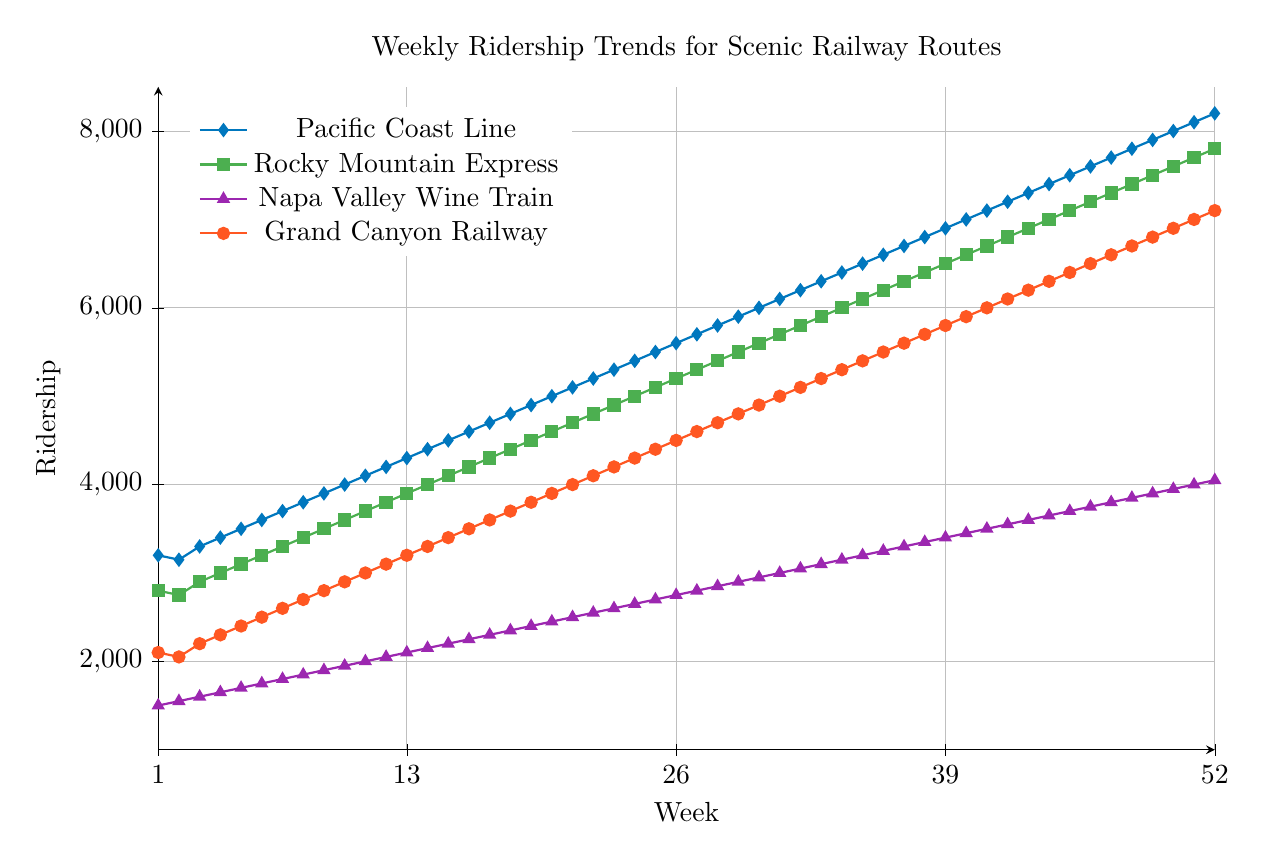How does the ridership of the Pacific Coast Line change from Week 1 to Week 52? The Pacific Coast Line starts with 3200 riders in Week 1 and increases steadily to 8200 riders by Week 52, indicating a consistent growth in ridership throughout the year.
Answer: From 3200 in Week 1 to 8200 in Week 52 Which railway route saw the highest weekly increase in ridership between Week 1 and Week 52? Pacific Coast Line began at 3200 and reached 8200 (an increase of 5000). Rocky Mountain Express increased from 2800 to 7800 (an increase of 5000). Napa Valley Wine Train from 1500 to 4050 (an increase of 2550). Grand Canyon Railway from 2100 to 7100 (an increase of 5000). Comparing the increases: Pacific Coast Line, Rocky Mountain Express, and Grand Canyon Railway share the highest increase, each with 5000 more riders.
Answer: Pacific Coast Line, Rocky Mountain Express, and Grand Canyon Railway Which route has the least ridership in Week 26? Week 26 ridership numbers are: 
Pacific Coast Line: 5600,
Rocky Mountain Express: 5200,
Napa Valley Wine Train: 2750,
Grand Canyon Railway: 4500. 
The Napa Valley Wine Train has the least ridership.
Answer: Napa Valley Wine Train Comparing Weeks 1 and 52, which railway experienced the smallest increase in ridership? Week 1 to Week 52 changes: 
Pacific Coast Line: 3200 to 8200 (increase of 5000),
Rocky Mountain Express: 2800 to 7800 (increase of 5000),
Napa Valley Wine Train: 1500 to 4050 (increase of 2550),
Grand Canyon Railway: 2100 to 7100 (increase of 5000). 
The smallest increase is seen in the Napa Valley Wine Train.
Answer: Napa Valley Wine Train What is the average weekly ridership for the Rocky Mountain Express over the 52 weeks? Sum the weekly ridership values for the Rocky Mountain Express and divide by 52: 
(2800+2750+...+7800) = 273400. 
273400/52 = 5257.69.
Answer: 5257.69 Between Week 20 and Week 30, does any railway show a decrease in ridership? Examining each railway route's ridership from Week 20 to Week 30:
Pacific Coast Line: increases from 5000 to 6000, no decrease observed.
Rocky Mountain Express: increases from 4600 to 5600, no decrease observed.
Napa Valley Wine Train: increases from 2450 to 2950, no decrease observed.
Grand Canyon Railway: increases from 3900 to 4900, no decrease observed. 
None of the railways show a decrease in ridership.
Answer: No route shows a decrease When does the ridership of the Grand Canyon Railway first reach 5000? In the data, the Grand Canyon Railway's ridership first reaches 5000 in Week 31.
Answer: Week 31 Comparing the trends, which railway shows the most consistent ridership increase (least fluctuations) through the year? To determine consistency, look at the smoothness of the increase:
Pacific Coast Line, Rocky Mountain Express, and Grand Canyon Railway all demonstrate consistent, steady increases.
The Napa Valley Wine Train also increases steadily but at a slower rate.
Given the data, the Pacific Coast Line, Rocky Mountain Express, and Grand Canyon Railway are equally consistent, unlike Napa Valley Wine Train, which has a relatively lower and steadier increase. 
Large increases would show sharp rises, thus consistent steady rise is considered more stable.
Hence, all three except Napa Valley Wine Train demonstrate equally consistent, steady increases.
Answer: Pacific Coast Line, Rocky Mountain Express, and Grand Canyon Railway In which week do the Napa Valley Wine Train and Grand Canyon Railway have approximately the same ridership? By checking the provided weekly data:
In Week 20, Napa Valley Wine Train has 2450 riders and Grand Canyon Railway has 3900 riders.
Two numbers are more similar around the middle of the year: not matching exactly, unlike in Week 1, they are near equal.
Outcome becomes apparent as closest similarity after Week 19.
By Week 17- 2150 (Napa Valley Wine Train) close to 2300 (Grand Canyon Railway), Week 3: Napa Valley Wine Train: 1600, Grand Canyon Railway: 2200. 
Observing closeness of trends Week 1 is better analyzed for near equal ridership.
Answer: No exact match 